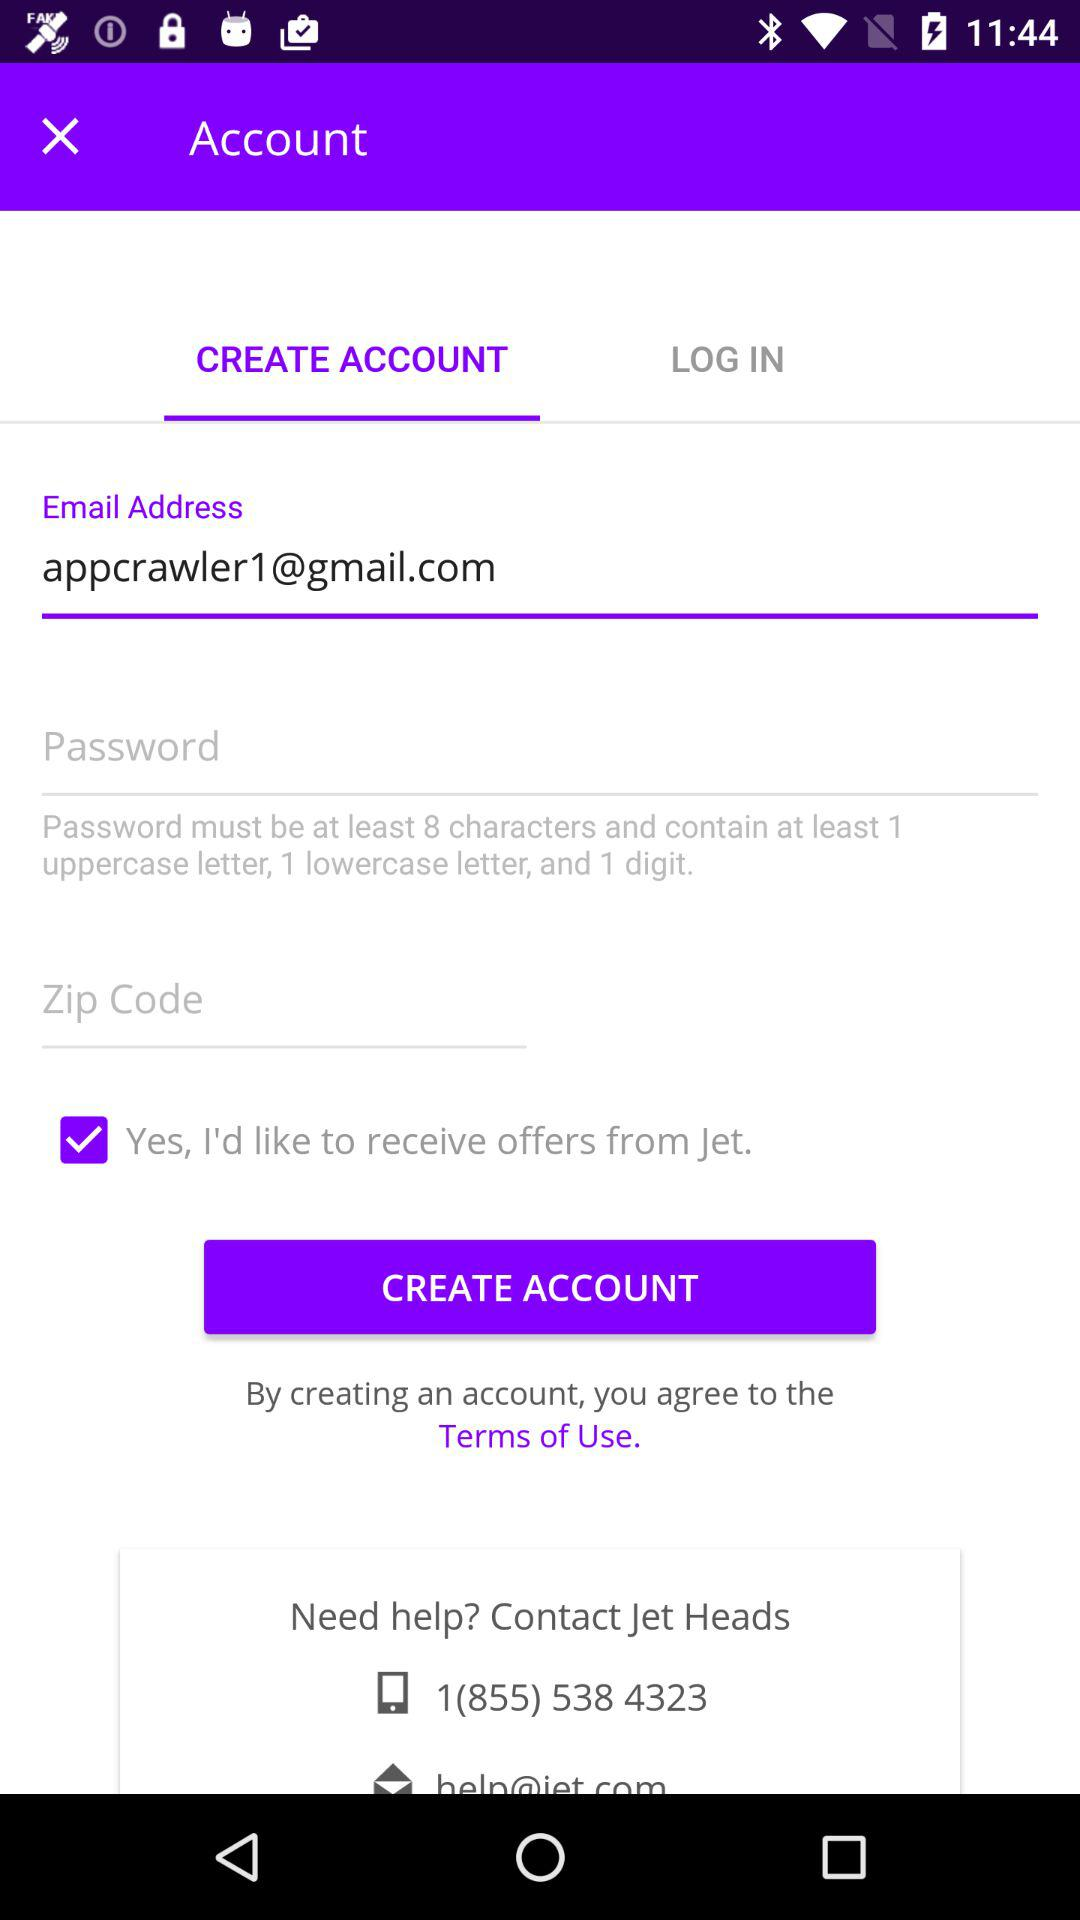What is the mobile number given for help? The given mobile number is 1(855) 538 4323. 